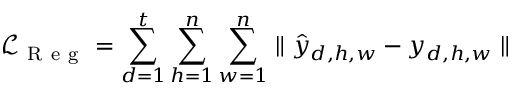Convert formula to latex. <formula><loc_0><loc_0><loc_500><loc_500>\mathcal { L } _ { R e g } = \sum _ { d = 1 } ^ { t } \sum _ { h = 1 } ^ { n } \sum _ { w = 1 } ^ { n } \| \hat { y } _ { d , h , w } - y _ { d , h , w } \|</formula> 